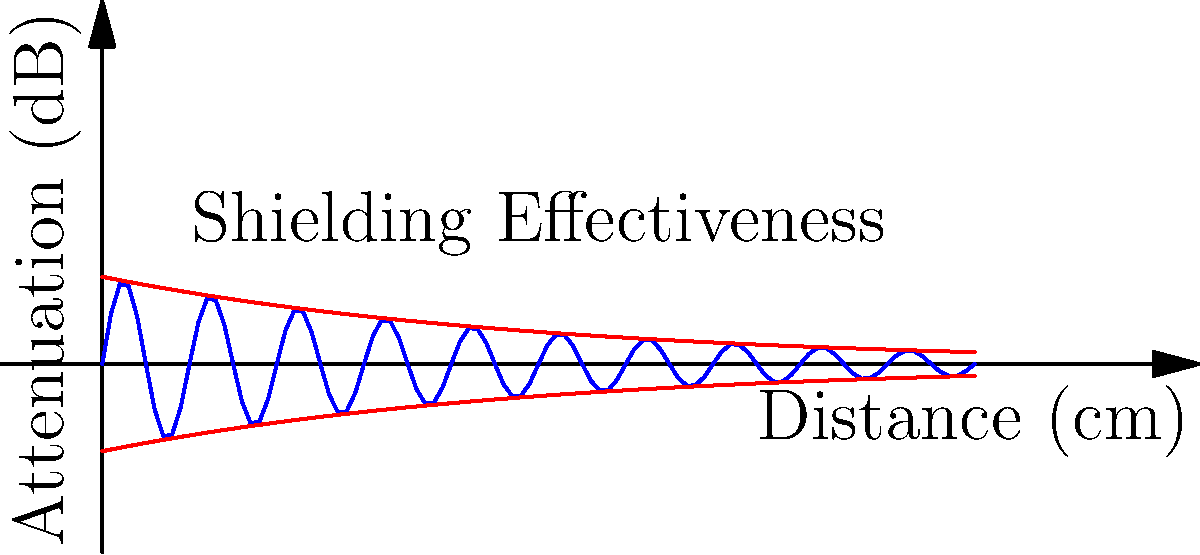In the context of electromagnetic interference (EMI) shielding for cross-border data transfer equipment, the graph above represents the shielding effectiveness of a certain material. What phenomenon does the oscillating blue curve between the two red exponential decay curves most likely represent, and how might this impact the selection of shielding materials for international data centers? To answer this question, let's analyze the graph step-by-step:

1. The x-axis represents distance in centimeters, while the y-axis represents attenuation in decibels (dB).

2. The two red curves show an exponential decay, which is typical of the overall shielding effectiveness of a material as electromagnetic waves penetrate deeper.

3. The blue curve oscillates between these two red curves, showing a sinusoidal pattern superimposed on the exponential decay.

4. This oscillating pattern is characteristic of multiple reflections or standing waves within the shielding material.

5. In EMI shielding, when an electromagnetic wave encounters a boundary between two materials (e.g., air and the shielding material), part of the wave is reflected, and part is transmitted.

6. The transmitted wave can then reflect off the opposite boundary of the shielding material, creating multiple internal reflections.

7. These multiple reflections can constructively or destructively interfere, leading to the observed oscillating pattern in shielding effectiveness.

8. This phenomenon is known as "re-reflection" or "multiple reflection effect" in EMI shielding.

9. For international data centers, this effect is crucial to consider because:
   a. It can create frequency-dependent variations in shielding effectiveness.
   b. It may lead to unexpected "windows" of reduced shielding at specific frequencies.
   c. The effect can vary with the thickness of the shielding material.

10. When selecting shielding materials for cross-border data transfer equipment, engineers must:
    a. Choose materials and thicknesses that minimize these re-reflection effects.
    b. Ensure consistent shielding across a wide frequency range to account for different international EMI standards.
    c. Consider multi-layer shielding solutions that can mitigate these effects.

11. Understanding this phenomenon is crucial for compliance with various international EMI regulations and ensuring reliable data transfer across borders.
Answer: Multiple reflection effect 